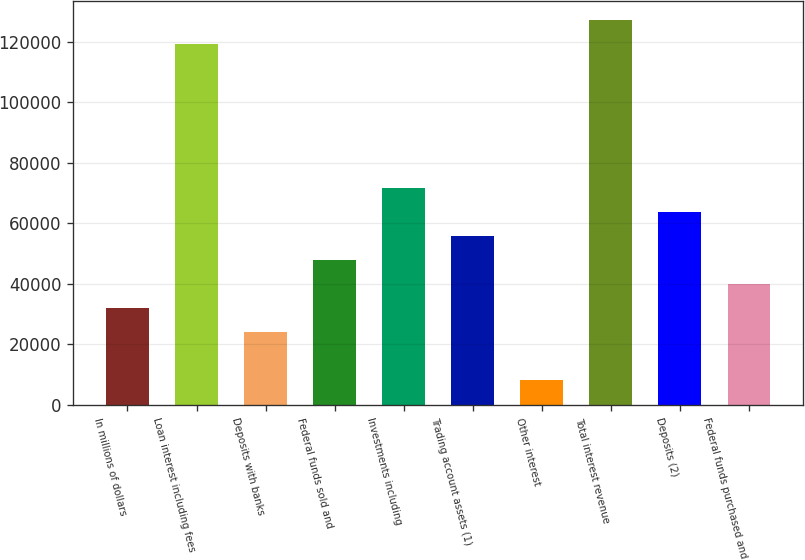<chart> <loc_0><loc_0><loc_500><loc_500><bar_chart><fcel>In millions of dollars<fcel>Loan interest including fees<fcel>Deposits with banks<fcel>Federal funds sold and<fcel>Investments including<fcel>Trading account assets (1)<fcel>Other interest<fcel>Total interest revenue<fcel>Deposits (2)<fcel>Federal funds purchased and<nl><fcel>32033.8<fcel>119084<fcel>24120.1<fcel>47861.2<fcel>71602.3<fcel>55774.9<fcel>8292.7<fcel>126998<fcel>63688.6<fcel>39947.5<nl></chart> 